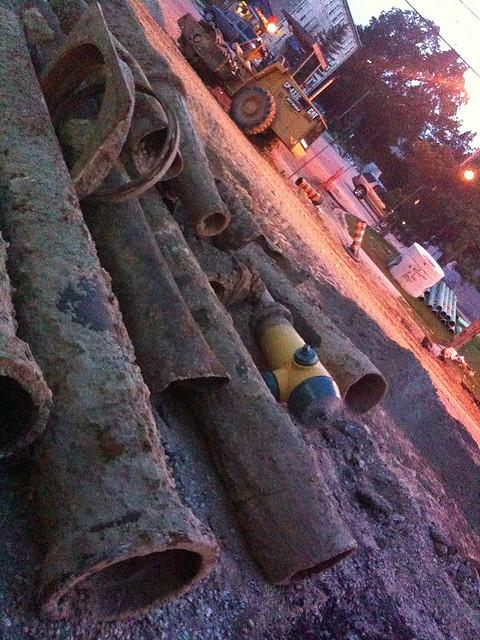What type of site is this? Please explain your reasoning. construction. There is an industrial vehicle, a lot of mud and large underground pipes in a pile. 